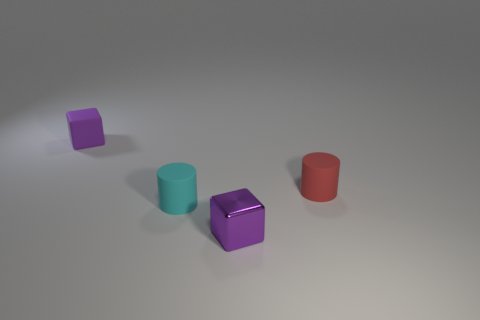Is there a purple metal thing that has the same size as the purple matte cube?
Your answer should be compact. Yes. Is the number of red matte objects that are behind the tiny cyan matte thing greater than the number of purple matte blocks behind the small rubber block?
Provide a short and direct response. Yes. Are the cyan object and the red thing that is in front of the purple matte object made of the same material?
Ensure brevity in your answer.  Yes. How many tiny matte cylinders are behind the small cube that is in front of the cylinder that is to the left of the purple shiny block?
Your response must be concise. 2. There is a red thing; is its shape the same as the matte thing behind the tiny red rubber object?
Offer a terse response. No. There is a rubber object that is on the right side of the tiny purple matte block and to the left of the small purple shiny object; what is its color?
Keep it short and to the point. Cyan. What is the material of the purple object that is in front of the tiny rubber thing on the right side of the tiny purple thing that is in front of the tiny red matte cylinder?
Provide a succinct answer. Metal. What is the material of the red object?
Provide a succinct answer. Rubber. Does the small metal block have the same color as the small rubber block?
Provide a short and direct response. Yes. What number of other objects are there of the same material as the tiny cyan cylinder?
Provide a succinct answer. 2. 